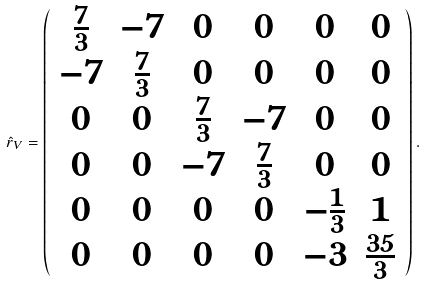Convert formula to latex. <formula><loc_0><loc_0><loc_500><loc_500>\hat { r } _ { V } = \left ( \begin{array} { c c c c c c } \frac { 7 } { 3 } & - 7 & 0 & 0 & 0 & 0 \\ - 7 & \frac { 7 } { 3 } & 0 & 0 & 0 & 0 \\ 0 & 0 & \frac { 7 } { 3 } & - 7 & 0 & 0 \\ 0 & 0 & - 7 & \frac { 7 } { 3 } & 0 & 0 \\ 0 & 0 & 0 & 0 & - \frac { 1 } { 3 } & 1 \\ 0 & 0 & 0 & 0 & - 3 & \frac { 3 5 } { 3 } \end{array} \right ) .</formula> 